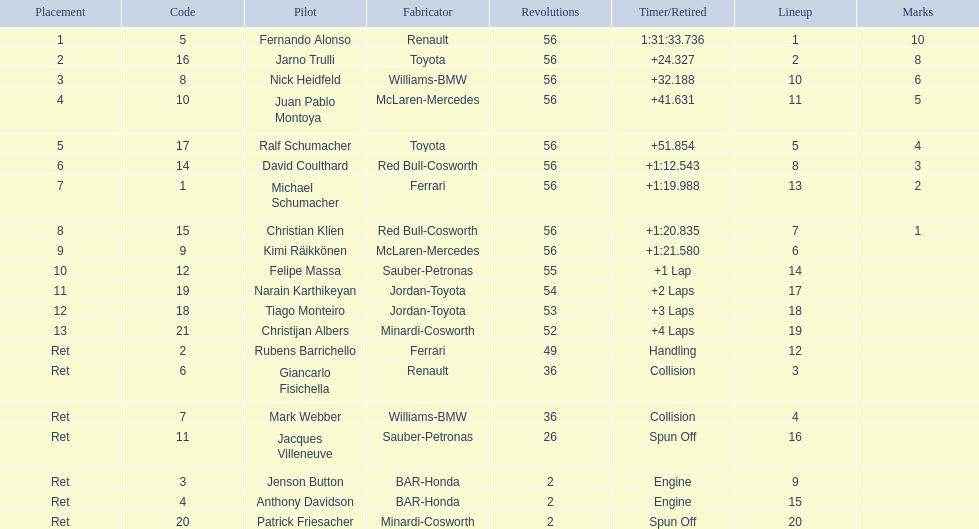Who raced during the 2005 malaysian grand prix? Fernando Alonso, Jarno Trulli, Nick Heidfeld, Juan Pablo Montoya, Ralf Schumacher, David Coulthard, Michael Schumacher, Christian Klien, Kimi Räikkönen, Felipe Massa, Narain Karthikeyan, Tiago Monteiro, Christijan Albers, Rubens Barrichello, Giancarlo Fisichella, Mark Webber, Jacques Villeneuve, Jenson Button, Anthony Davidson, Patrick Friesacher. What were their finishing times? 1:31:33.736, +24.327, +32.188, +41.631, +51.854, +1:12.543, +1:19.988, +1:20.835, +1:21.580, +1 Lap, +2 Laps, +3 Laps, +4 Laps, Handling, Collision, Collision, Spun Off, Engine, Engine, Spun Off. What was fernando alonso's finishing time? 1:31:33.736. 